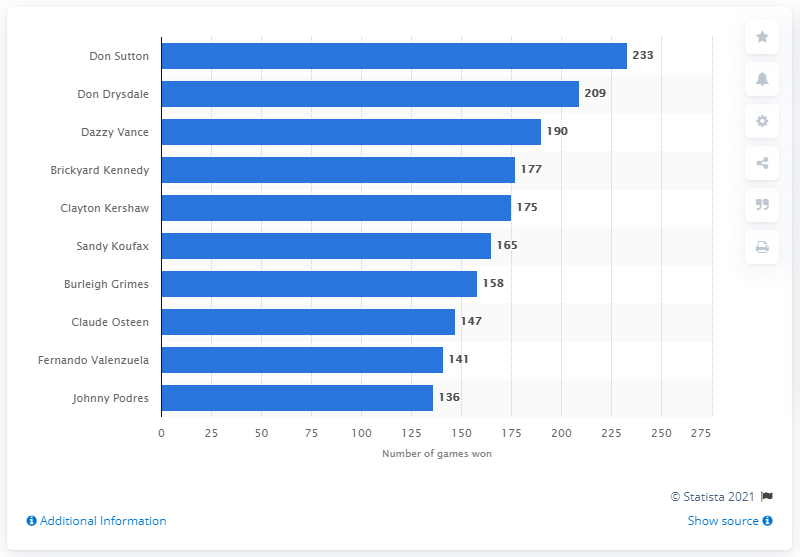Mention a couple of crucial points in this snapshot. The winner of the most games in the history of the Los Angeles Dodgers franchise is Don Sutton. Don Sutton has won a record 233 games in the history of the Los Angeles Dodgers. In two games, Clayton Kershaw is leading the pack, with Brickyard Kennedy close behind. It is estimated that 10 leaders are considered in the process. 